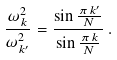Convert formula to latex. <formula><loc_0><loc_0><loc_500><loc_500>\frac { \omega ^ { 2 } _ { k } } { \omega ^ { 2 } _ { k ^ { \prime } } } = \frac { \sin \frac { \pi \, k ^ { \prime } } { N } } { \sin \frac { \pi \, k } { N } } \, .</formula> 